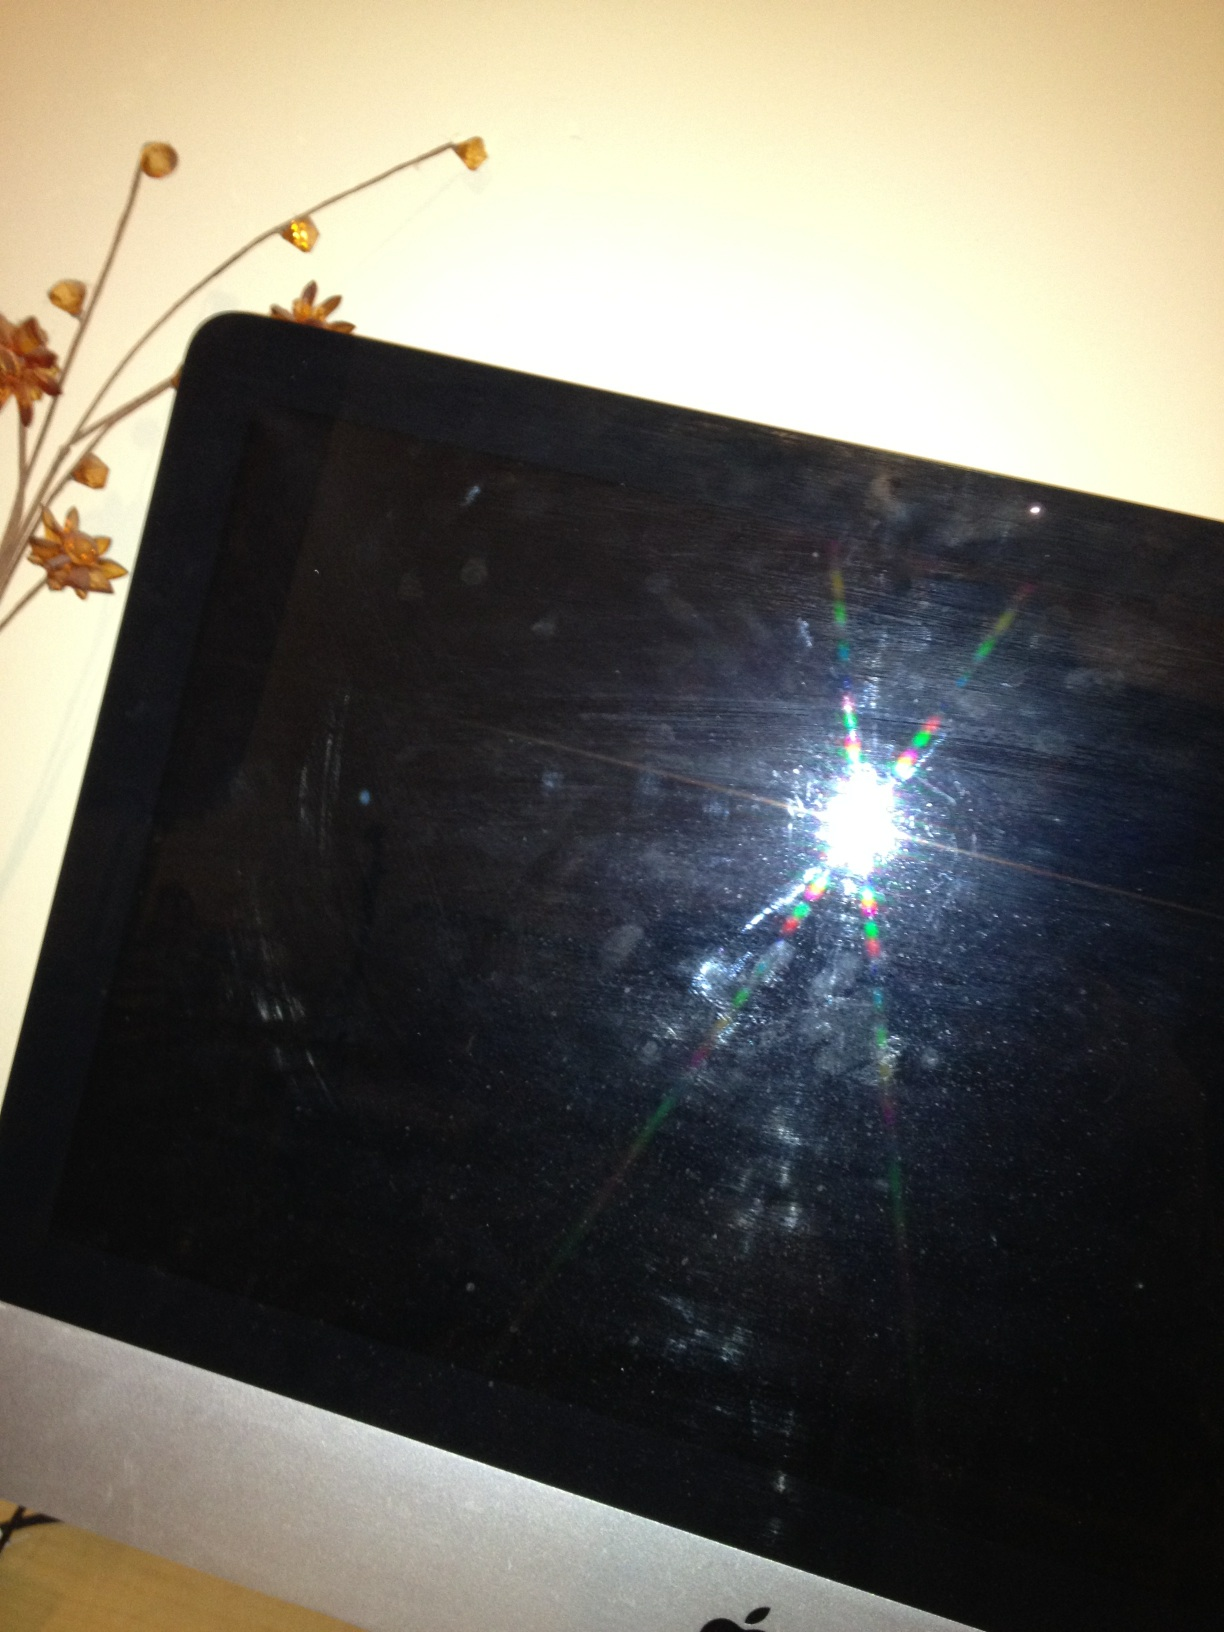What kind of activities can you see happening around this setup? Around this setup, various activities might take place. It could be used for work, with someone typing away at their daily tasks or attending virtual meetings. It might also serve as an entertainment hub for watching movies, playing video games, or browsing the internet. Additionally, this space could be used for creative endeavors like digital art, design, or writing. If someone were to sit down at this setup, what might they use it for? If someone were to sit down at this setup, they might use it to complete their work assignments or school projects. They could be checking emails, drafting documents, or coding software. Alternatively, they might use it to watch their favorite TV shows, stream music, connect with friends and family via video calls, or even engage in some online shopping. Describe a day in the life of someone using this setup in great detail. A typical day starts with the hum of the computer and a fresh cup of coffee. The user logs in, greeted by the tranquil morning light filtering through the window. Emails are the first task, each one carrying its weight of tasks and appointments. As the morning progresses, the screen glows with spreadsheets, documents, and reports. Video calls punctuate the quiet atmosphere, bringing faces and voices from different places. Lunch is a quick affair, maybe enjoyed while browsing news articles or catching up on social media. The afternoon might shift to more creative tasks: designing a presentation, editing a video, or brainstorming ideas on a digital whiteboard. As the evening sets in, the screen transforms into an entertainment hub, streaming the latest movie or facilitating a virtual meet-up with friends. The day winds down with a bit of online shopping or reading a digital book before the screen darkens and silence takes over, signaling the end of another productive day. If you were a character from a magical realm, what would you do with this screen? As a character from a magical realm, I would use this screen as a portal to view different dimensions and realms. It would be a magical device that shows the past, present, and future of various worlds. With a spell, I could access ancient libraries, watch over mystical creatures, or even communicate with other magical beings across the multiverse. The screen would glow with arcane symbols and vibrant images whenever it's activated by a unique incantation. In a realistic scenario, why might someone leave their screen this dirty? In a realistic scenario, someone might leave their screen dirty due to a busy schedule and not having the time to clean it. It could also be due to a lack of awareness of how dirty the screen has gotten over time or simply not prioritizing screen cleanliness as it doesn’t significantly affect their day-to-day usage of the device. 